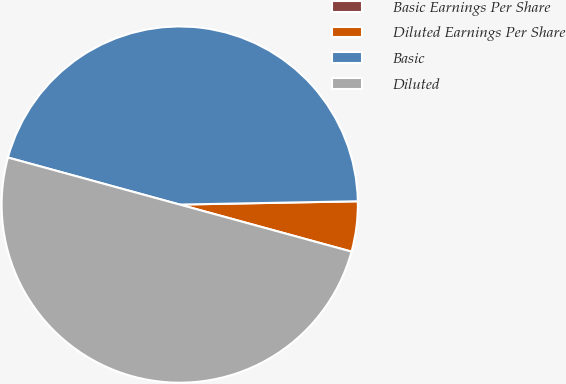Convert chart to OTSL. <chart><loc_0><loc_0><loc_500><loc_500><pie_chart><fcel>Basic Earnings Per Share<fcel>Diluted Earnings Per Share<fcel>Basic<fcel>Diluted<nl><fcel>0.0%<fcel>4.55%<fcel>45.45%<fcel>50.0%<nl></chart> 